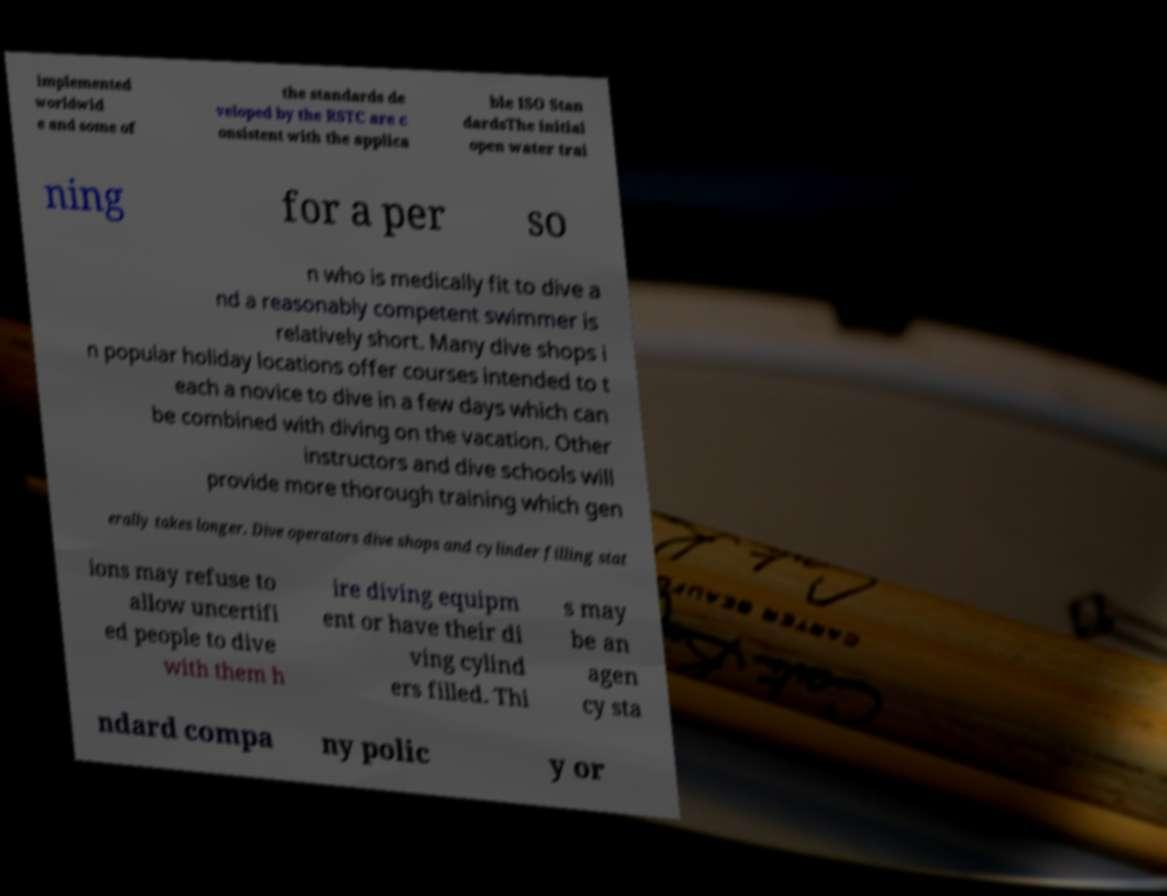For documentation purposes, I need the text within this image transcribed. Could you provide that? implemented worldwid e and some of the standards de veloped by the RSTC are c onsistent with the applica ble ISO Stan dardsThe initial open water trai ning for a per so n who is medically fit to dive a nd a reasonably competent swimmer is relatively short. Many dive shops i n popular holiday locations offer courses intended to t each a novice to dive in a few days which can be combined with diving on the vacation. Other instructors and dive schools will provide more thorough training which gen erally takes longer. Dive operators dive shops and cylinder filling stat ions may refuse to allow uncertifi ed people to dive with them h ire diving equipm ent or have their di ving cylind ers filled. Thi s may be an agen cy sta ndard compa ny polic y or 